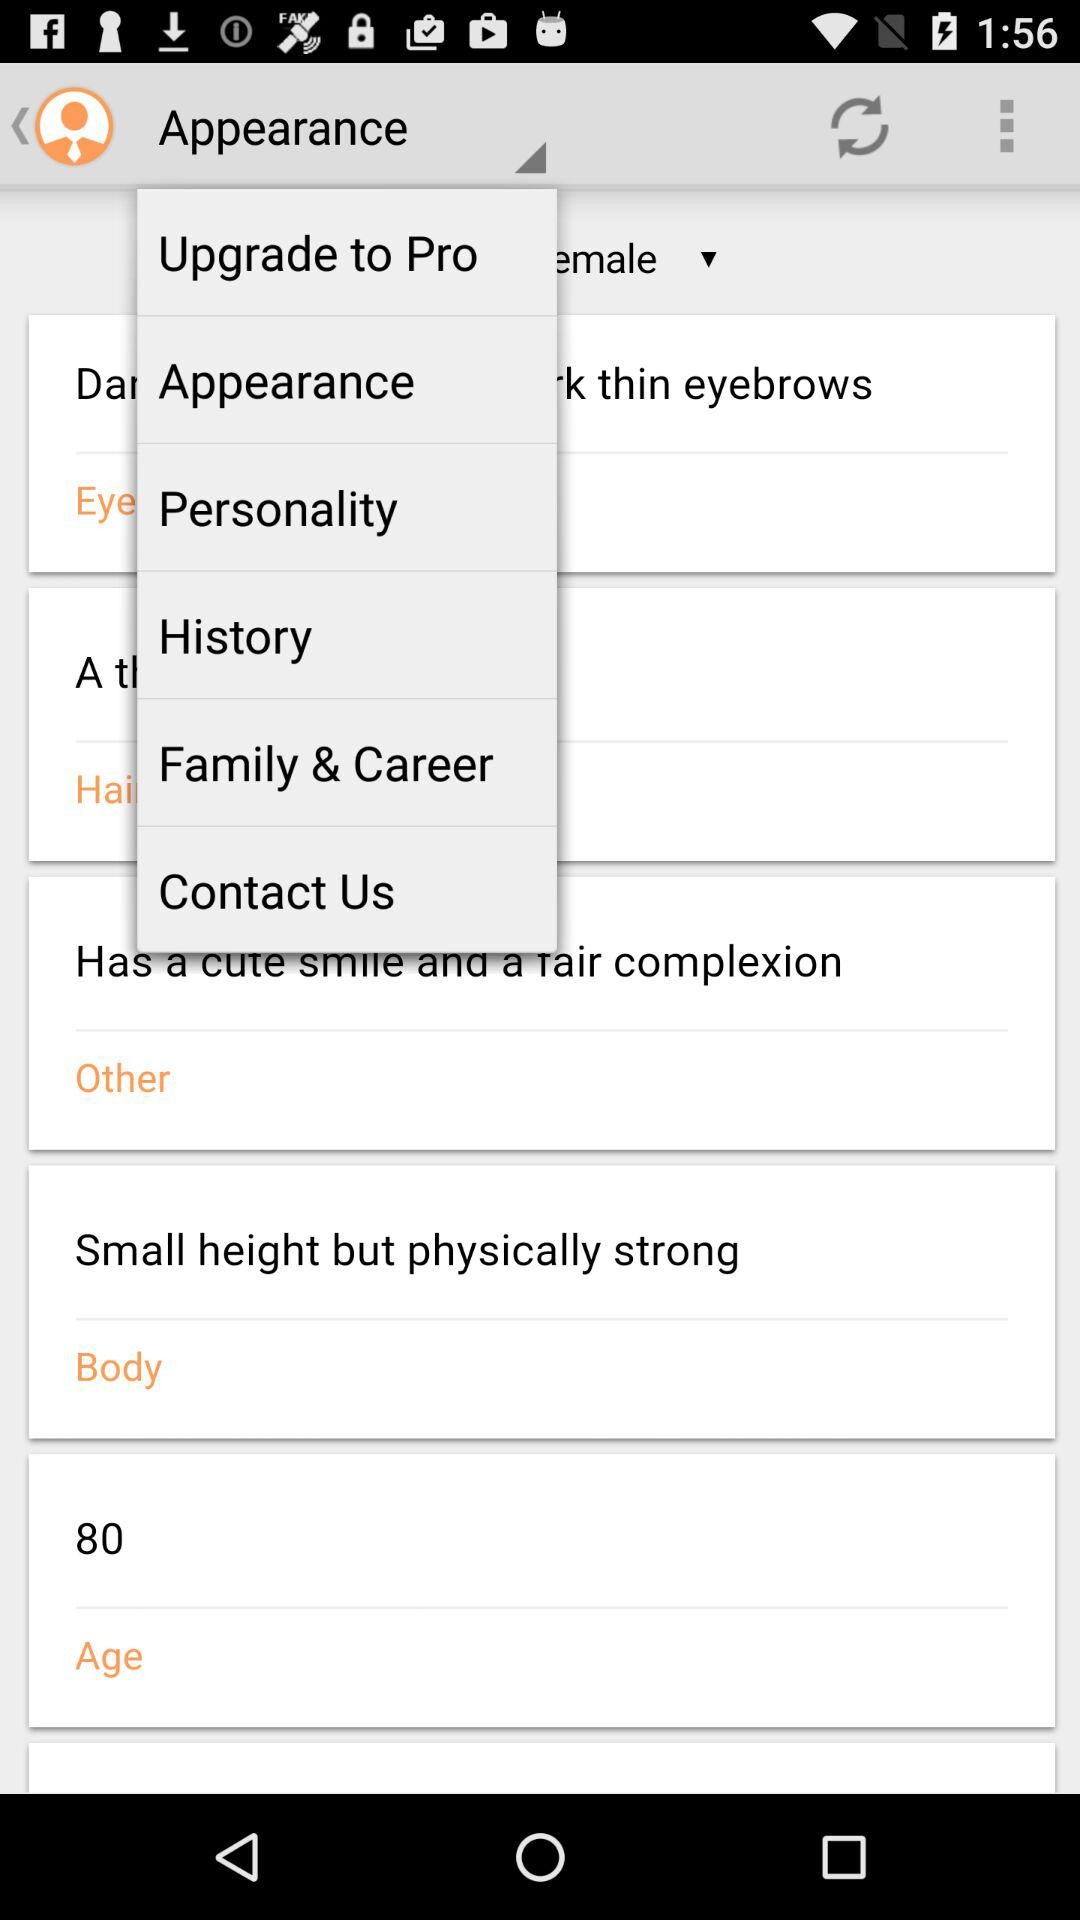How many notifications are there in "History"?
When the provided information is insufficient, respond with <no answer>. <no answer> 